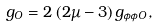<formula> <loc_0><loc_0><loc_500><loc_500>g _ { O } = 2 \, ( 2 \mu - 3 ) \, g _ { \phi \phi O } ,</formula> 